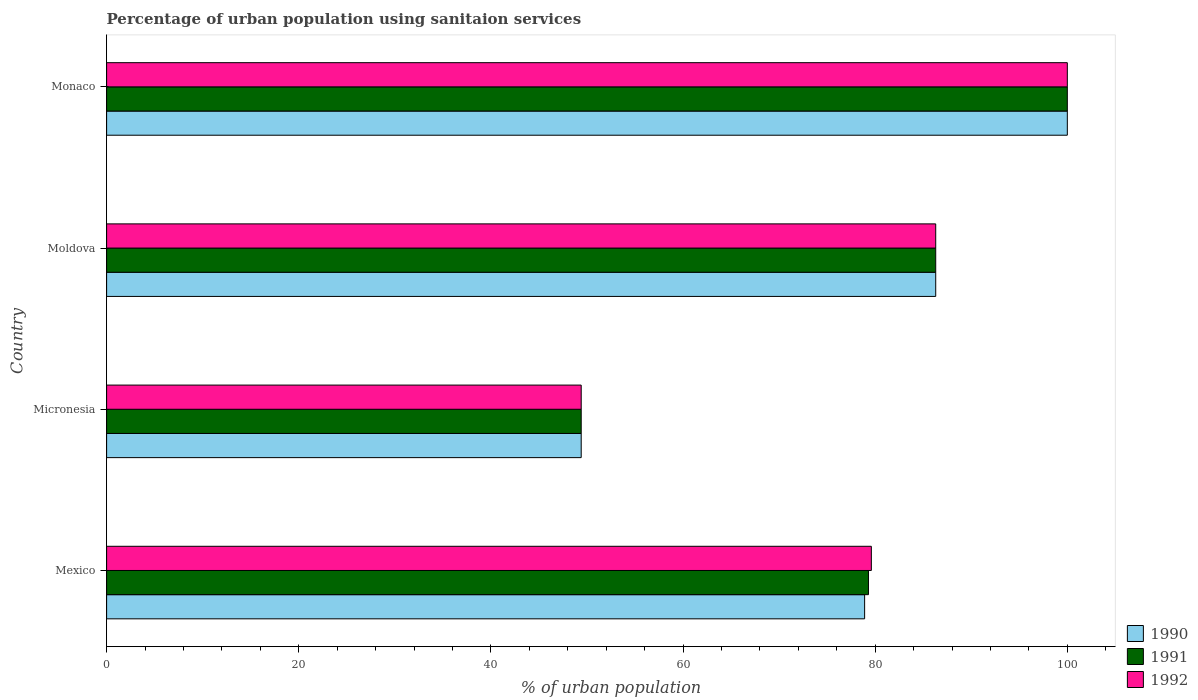How many different coloured bars are there?
Provide a short and direct response. 3. Are the number of bars on each tick of the Y-axis equal?
Give a very brief answer. Yes. How many bars are there on the 3rd tick from the top?
Give a very brief answer. 3. What is the label of the 3rd group of bars from the top?
Ensure brevity in your answer.  Micronesia. In how many cases, is the number of bars for a given country not equal to the number of legend labels?
Provide a succinct answer. 0. What is the percentage of urban population using sanitaion services in 1991 in Micronesia?
Your answer should be compact. 49.4. Across all countries, what is the minimum percentage of urban population using sanitaion services in 1991?
Ensure brevity in your answer.  49.4. In which country was the percentage of urban population using sanitaion services in 1992 maximum?
Provide a short and direct response. Monaco. In which country was the percentage of urban population using sanitaion services in 1992 minimum?
Your answer should be compact. Micronesia. What is the total percentage of urban population using sanitaion services in 1990 in the graph?
Your answer should be very brief. 314.6. What is the difference between the percentage of urban population using sanitaion services in 1991 in Moldova and that in Monaco?
Your answer should be compact. -13.7. What is the difference between the percentage of urban population using sanitaion services in 1990 in Moldova and the percentage of urban population using sanitaion services in 1991 in Micronesia?
Provide a short and direct response. 36.9. What is the average percentage of urban population using sanitaion services in 1990 per country?
Your response must be concise. 78.65. What is the difference between the percentage of urban population using sanitaion services in 1991 and percentage of urban population using sanitaion services in 1992 in Mexico?
Your response must be concise. -0.3. In how many countries, is the percentage of urban population using sanitaion services in 1992 greater than 36 %?
Keep it short and to the point. 4. What is the ratio of the percentage of urban population using sanitaion services in 1990 in Micronesia to that in Monaco?
Keep it short and to the point. 0.49. Is the percentage of urban population using sanitaion services in 1990 in Mexico less than that in Micronesia?
Your response must be concise. No. Is the difference between the percentage of urban population using sanitaion services in 1991 in Micronesia and Moldova greater than the difference between the percentage of urban population using sanitaion services in 1992 in Micronesia and Moldova?
Provide a succinct answer. No. What is the difference between the highest and the second highest percentage of urban population using sanitaion services in 1991?
Provide a short and direct response. 13.7. What is the difference between the highest and the lowest percentage of urban population using sanitaion services in 1992?
Your response must be concise. 50.6. What does the 2nd bar from the top in Monaco represents?
Ensure brevity in your answer.  1991. What does the 1st bar from the bottom in Micronesia represents?
Your response must be concise. 1990. How are the legend labels stacked?
Make the answer very short. Vertical. What is the title of the graph?
Offer a terse response. Percentage of urban population using sanitaion services. What is the label or title of the X-axis?
Provide a short and direct response. % of urban population. What is the % of urban population of 1990 in Mexico?
Make the answer very short. 78.9. What is the % of urban population of 1991 in Mexico?
Provide a short and direct response. 79.3. What is the % of urban population in 1992 in Mexico?
Give a very brief answer. 79.6. What is the % of urban population of 1990 in Micronesia?
Give a very brief answer. 49.4. What is the % of urban population of 1991 in Micronesia?
Your response must be concise. 49.4. What is the % of urban population in 1992 in Micronesia?
Provide a succinct answer. 49.4. What is the % of urban population in 1990 in Moldova?
Your answer should be compact. 86.3. What is the % of urban population in 1991 in Moldova?
Your answer should be very brief. 86.3. What is the % of urban population in 1992 in Moldova?
Ensure brevity in your answer.  86.3. What is the % of urban population of 1991 in Monaco?
Offer a terse response. 100. What is the % of urban population of 1992 in Monaco?
Provide a short and direct response. 100. Across all countries, what is the maximum % of urban population of 1990?
Your answer should be compact. 100. Across all countries, what is the minimum % of urban population of 1990?
Ensure brevity in your answer.  49.4. Across all countries, what is the minimum % of urban population of 1991?
Your response must be concise. 49.4. Across all countries, what is the minimum % of urban population of 1992?
Provide a succinct answer. 49.4. What is the total % of urban population of 1990 in the graph?
Keep it short and to the point. 314.6. What is the total % of urban population in 1991 in the graph?
Offer a terse response. 315. What is the total % of urban population in 1992 in the graph?
Offer a terse response. 315.3. What is the difference between the % of urban population in 1990 in Mexico and that in Micronesia?
Your response must be concise. 29.5. What is the difference between the % of urban population in 1991 in Mexico and that in Micronesia?
Provide a short and direct response. 29.9. What is the difference between the % of urban population in 1992 in Mexico and that in Micronesia?
Your answer should be compact. 30.2. What is the difference between the % of urban population of 1990 in Mexico and that in Moldova?
Keep it short and to the point. -7.4. What is the difference between the % of urban population in 1992 in Mexico and that in Moldova?
Provide a short and direct response. -6.7. What is the difference between the % of urban population in 1990 in Mexico and that in Monaco?
Your answer should be compact. -21.1. What is the difference between the % of urban population of 1991 in Mexico and that in Monaco?
Provide a succinct answer. -20.7. What is the difference between the % of urban population in 1992 in Mexico and that in Monaco?
Give a very brief answer. -20.4. What is the difference between the % of urban population of 1990 in Micronesia and that in Moldova?
Provide a succinct answer. -36.9. What is the difference between the % of urban population of 1991 in Micronesia and that in Moldova?
Offer a very short reply. -36.9. What is the difference between the % of urban population of 1992 in Micronesia and that in Moldova?
Provide a short and direct response. -36.9. What is the difference between the % of urban population in 1990 in Micronesia and that in Monaco?
Offer a very short reply. -50.6. What is the difference between the % of urban population in 1991 in Micronesia and that in Monaco?
Give a very brief answer. -50.6. What is the difference between the % of urban population in 1992 in Micronesia and that in Monaco?
Provide a short and direct response. -50.6. What is the difference between the % of urban population in 1990 in Moldova and that in Monaco?
Ensure brevity in your answer.  -13.7. What is the difference between the % of urban population of 1991 in Moldova and that in Monaco?
Offer a very short reply. -13.7. What is the difference between the % of urban population in 1992 in Moldova and that in Monaco?
Give a very brief answer. -13.7. What is the difference between the % of urban population in 1990 in Mexico and the % of urban population in 1991 in Micronesia?
Keep it short and to the point. 29.5. What is the difference between the % of urban population of 1990 in Mexico and the % of urban population of 1992 in Micronesia?
Offer a very short reply. 29.5. What is the difference between the % of urban population in 1991 in Mexico and the % of urban population in 1992 in Micronesia?
Your answer should be compact. 29.9. What is the difference between the % of urban population in 1990 in Mexico and the % of urban population in 1991 in Moldova?
Provide a short and direct response. -7.4. What is the difference between the % of urban population of 1990 in Mexico and the % of urban population of 1992 in Moldova?
Offer a terse response. -7.4. What is the difference between the % of urban population in 1990 in Mexico and the % of urban population in 1991 in Monaco?
Provide a short and direct response. -21.1. What is the difference between the % of urban population in 1990 in Mexico and the % of urban population in 1992 in Monaco?
Offer a terse response. -21.1. What is the difference between the % of urban population in 1991 in Mexico and the % of urban population in 1992 in Monaco?
Your answer should be very brief. -20.7. What is the difference between the % of urban population of 1990 in Micronesia and the % of urban population of 1991 in Moldova?
Your answer should be compact. -36.9. What is the difference between the % of urban population of 1990 in Micronesia and the % of urban population of 1992 in Moldova?
Provide a short and direct response. -36.9. What is the difference between the % of urban population of 1991 in Micronesia and the % of urban population of 1992 in Moldova?
Provide a succinct answer. -36.9. What is the difference between the % of urban population in 1990 in Micronesia and the % of urban population in 1991 in Monaco?
Your answer should be compact. -50.6. What is the difference between the % of urban population of 1990 in Micronesia and the % of urban population of 1992 in Monaco?
Your answer should be compact. -50.6. What is the difference between the % of urban population of 1991 in Micronesia and the % of urban population of 1992 in Monaco?
Your answer should be very brief. -50.6. What is the difference between the % of urban population in 1990 in Moldova and the % of urban population in 1991 in Monaco?
Make the answer very short. -13.7. What is the difference between the % of urban population in 1990 in Moldova and the % of urban population in 1992 in Monaco?
Make the answer very short. -13.7. What is the difference between the % of urban population in 1991 in Moldova and the % of urban population in 1992 in Monaco?
Make the answer very short. -13.7. What is the average % of urban population in 1990 per country?
Your response must be concise. 78.65. What is the average % of urban population in 1991 per country?
Give a very brief answer. 78.75. What is the average % of urban population in 1992 per country?
Provide a short and direct response. 78.83. What is the difference between the % of urban population of 1990 and % of urban population of 1992 in Mexico?
Give a very brief answer. -0.7. What is the difference between the % of urban population in 1991 and % of urban population in 1992 in Mexico?
Provide a succinct answer. -0.3. What is the difference between the % of urban population of 1990 and % of urban population of 1992 in Micronesia?
Offer a terse response. 0. What is the difference between the % of urban population in 1990 and % of urban population in 1991 in Moldova?
Offer a terse response. 0. What is the difference between the % of urban population in 1990 and % of urban population in 1992 in Moldova?
Offer a terse response. 0. What is the difference between the % of urban population of 1991 and % of urban population of 1992 in Moldova?
Offer a terse response. 0. What is the difference between the % of urban population of 1990 and % of urban population of 1991 in Monaco?
Your answer should be very brief. 0. What is the difference between the % of urban population of 1991 and % of urban population of 1992 in Monaco?
Offer a very short reply. 0. What is the ratio of the % of urban population of 1990 in Mexico to that in Micronesia?
Make the answer very short. 1.6. What is the ratio of the % of urban population of 1991 in Mexico to that in Micronesia?
Ensure brevity in your answer.  1.61. What is the ratio of the % of urban population in 1992 in Mexico to that in Micronesia?
Your response must be concise. 1.61. What is the ratio of the % of urban population in 1990 in Mexico to that in Moldova?
Your answer should be very brief. 0.91. What is the ratio of the % of urban population of 1991 in Mexico to that in Moldova?
Provide a succinct answer. 0.92. What is the ratio of the % of urban population in 1992 in Mexico to that in Moldova?
Ensure brevity in your answer.  0.92. What is the ratio of the % of urban population in 1990 in Mexico to that in Monaco?
Offer a terse response. 0.79. What is the ratio of the % of urban population of 1991 in Mexico to that in Monaco?
Give a very brief answer. 0.79. What is the ratio of the % of urban population in 1992 in Mexico to that in Monaco?
Offer a very short reply. 0.8. What is the ratio of the % of urban population in 1990 in Micronesia to that in Moldova?
Your answer should be compact. 0.57. What is the ratio of the % of urban population of 1991 in Micronesia to that in Moldova?
Give a very brief answer. 0.57. What is the ratio of the % of urban population of 1992 in Micronesia to that in Moldova?
Keep it short and to the point. 0.57. What is the ratio of the % of urban population in 1990 in Micronesia to that in Monaco?
Your answer should be compact. 0.49. What is the ratio of the % of urban population of 1991 in Micronesia to that in Monaco?
Offer a very short reply. 0.49. What is the ratio of the % of urban population in 1992 in Micronesia to that in Monaco?
Provide a short and direct response. 0.49. What is the ratio of the % of urban population of 1990 in Moldova to that in Monaco?
Ensure brevity in your answer.  0.86. What is the ratio of the % of urban population in 1991 in Moldova to that in Monaco?
Ensure brevity in your answer.  0.86. What is the ratio of the % of urban population of 1992 in Moldova to that in Monaco?
Offer a terse response. 0.86. What is the difference between the highest and the second highest % of urban population of 1990?
Give a very brief answer. 13.7. What is the difference between the highest and the lowest % of urban population in 1990?
Keep it short and to the point. 50.6. What is the difference between the highest and the lowest % of urban population of 1991?
Provide a short and direct response. 50.6. What is the difference between the highest and the lowest % of urban population of 1992?
Your answer should be very brief. 50.6. 